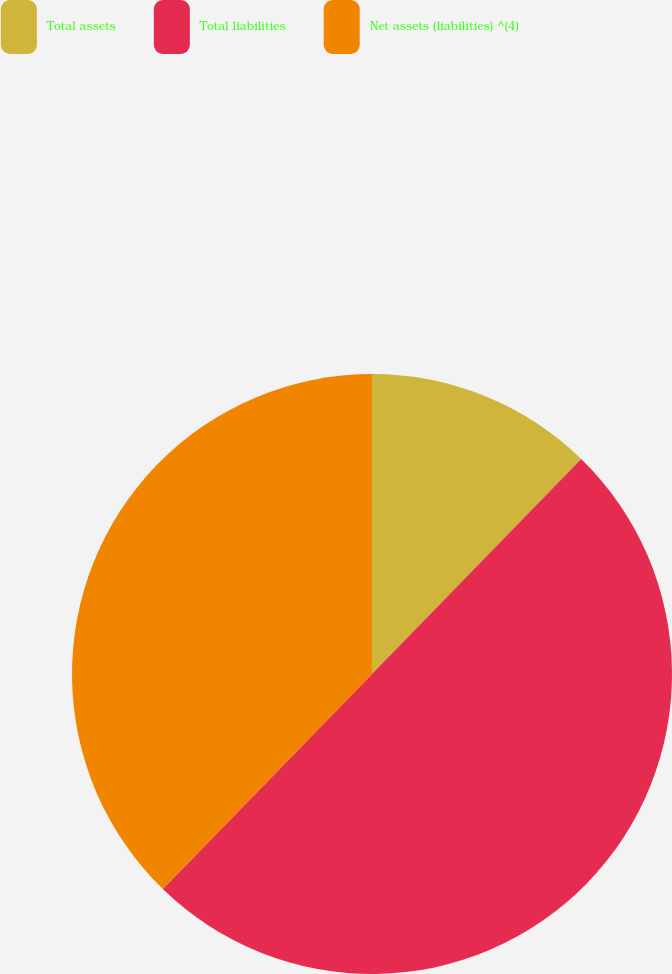Convert chart to OTSL. <chart><loc_0><loc_0><loc_500><loc_500><pie_chart><fcel>Total assets<fcel>Total liabilities<fcel>Net assets (liabilities) ^(4)<nl><fcel>12.28%<fcel>50.0%<fcel>37.72%<nl></chart> 